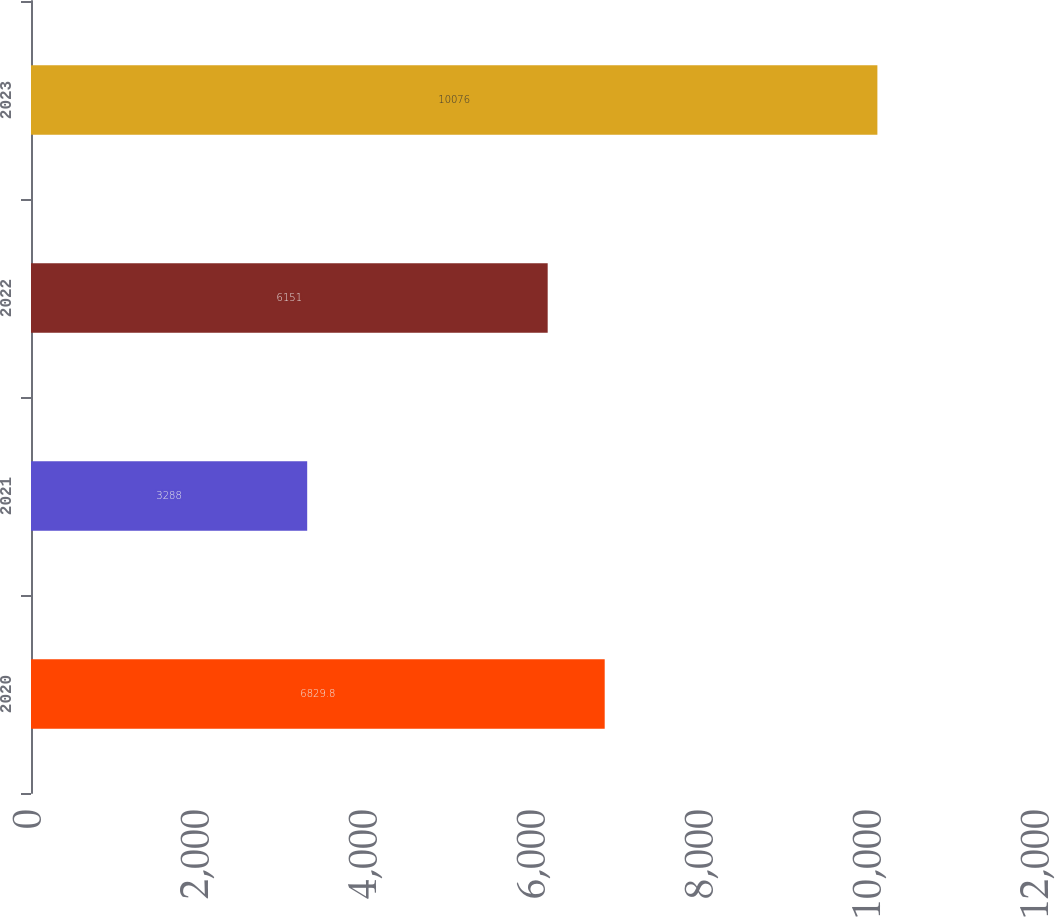Convert chart to OTSL. <chart><loc_0><loc_0><loc_500><loc_500><bar_chart><fcel>2020<fcel>2021<fcel>2022<fcel>2023<nl><fcel>6829.8<fcel>3288<fcel>6151<fcel>10076<nl></chart> 